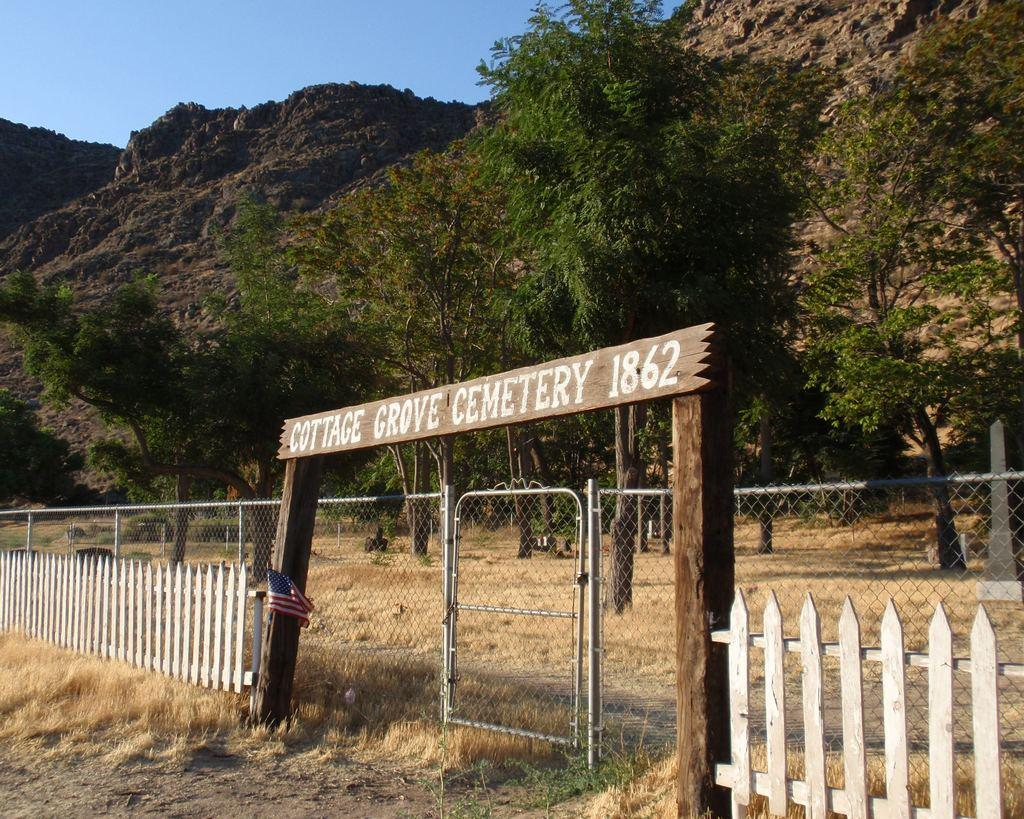What type of structure can be seen in the image? There is fencing in the image. What can be seen in the background of the image? There are trees and a mountain in the background of the image. What is visible in the sky in the image? The sky is visible in the background of the image. What type of cap can be seen on the mountain in the image? There is no cap visible on the mountain in the image; it is a natural formation. 